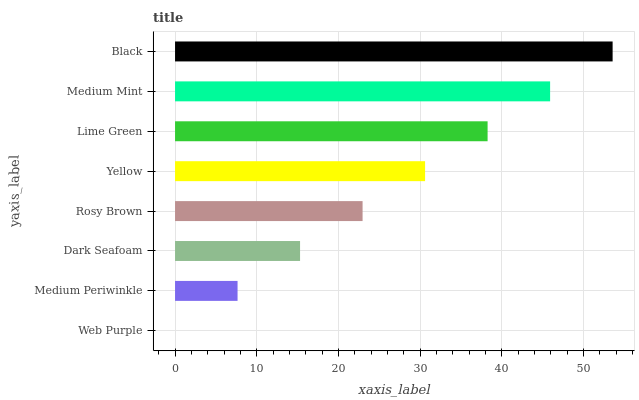Is Web Purple the minimum?
Answer yes or no. Yes. Is Black the maximum?
Answer yes or no. Yes. Is Medium Periwinkle the minimum?
Answer yes or no. No. Is Medium Periwinkle the maximum?
Answer yes or no. No. Is Medium Periwinkle greater than Web Purple?
Answer yes or no. Yes. Is Web Purple less than Medium Periwinkle?
Answer yes or no. Yes. Is Web Purple greater than Medium Periwinkle?
Answer yes or no. No. Is Medium Periwinkle less than Web Purple?
Answer yes or no. No. Is Yellow the high median?
Answer yes or no. Yes. Is Rosy Brown the low median?
Answer yes or no. Yes. Is Lime Green the high median?
Answer yes or no. No. Is Lime Green the low median?
Answer yes or no. No. 